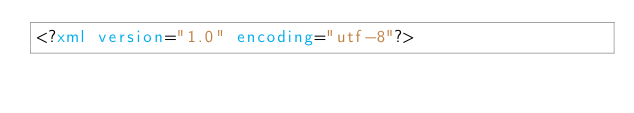Convert code to text. <code><loc_0><loc_0><loc_500><loc_500><_XML_><?xml version="1.0" encoding="utf-8"?></code> 